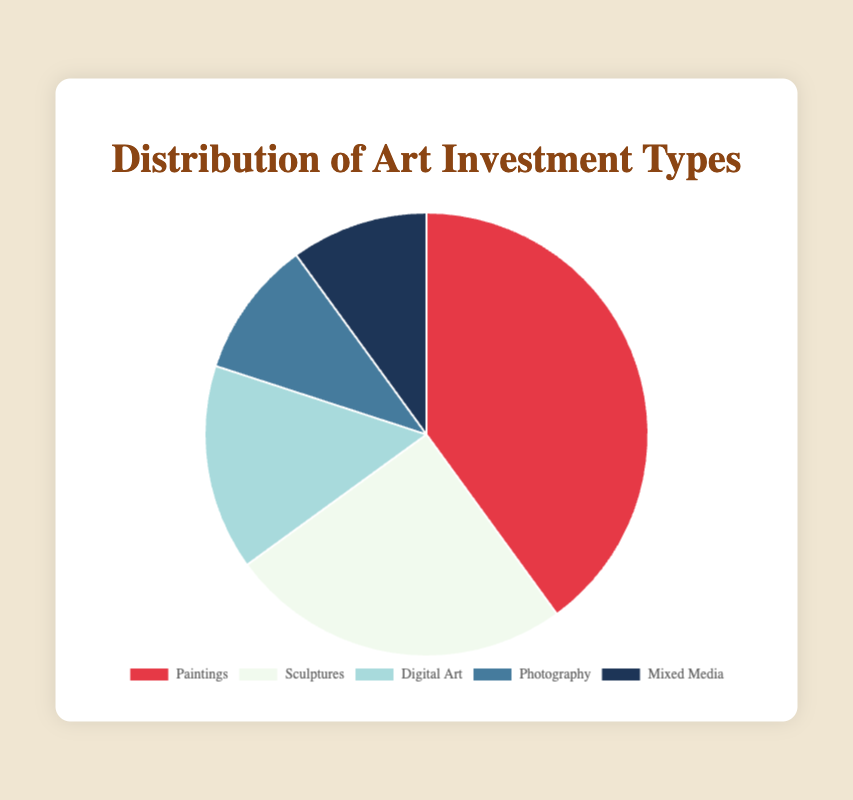What percentage of the total investment is allocated to Paintings and Sculptures combined? The pie chart shows Paintings have a 40% distribution and Sculptures have a 25% distribution. To find the combined percentage, we simply add these two values: 40% + 25% = 65%
Answer: 65% Which type of art investment has the smallest allocation? By observing the pie chart, Photography and Mixed Media both share the smallest allocation at 10% each of the total investment
Answer: Photography and Mixed Media If you combined Digital Art and Photography investments, what would their total percentage be? The chart shows Digital Art at 15% and Photography at 10%. Adding these values gives us 15% + 10% = 25%
Answer: 25% Which investment type is represented by the darkest color slice in the pie chart? The pie chart indicates that the darkest color slice represents the Mixed Media, which has a 10% distribution
Answer: Mixed Media Are there any art investment types that have equal allocations? If so, which are they? By looking at the pie chart, Photography and Mixed Media each have an equal allocation of 10%
Answer: Photography and Mixed Media What is the difference in allocation between the highest and lowest investment types? The highest allocation is for Paintings at 40%, and the lowest is shared by Photography and Mixed Media at 10%. The difference is 40% - 10% = 30%
Answer: 30% How do Sculptures compare to Digital Art in terms of allocation? Sculptures have a 25% distribution, while Digital Art has 15%. Sculptures have a higher allocation by 10 percentage points
Answer: Sculptures have a higher allocation If you wanted to represent the portfolio predominantly by one investment type, which would it be and why? Paintings have the highest allocation in the pie chart at 40%, making them the most prominent type of art investment in this distribution
Answer: Paintings What combined percentage of the investment portfolio consists of art forms other than Paintings? By excluding Paintings (40%), we sum the remaining art forms' percentages: Sculptures (25%) + Digital Art (15%) + Photography (10%) + Mixed Media (10%) = 60%
Answer: 60% 